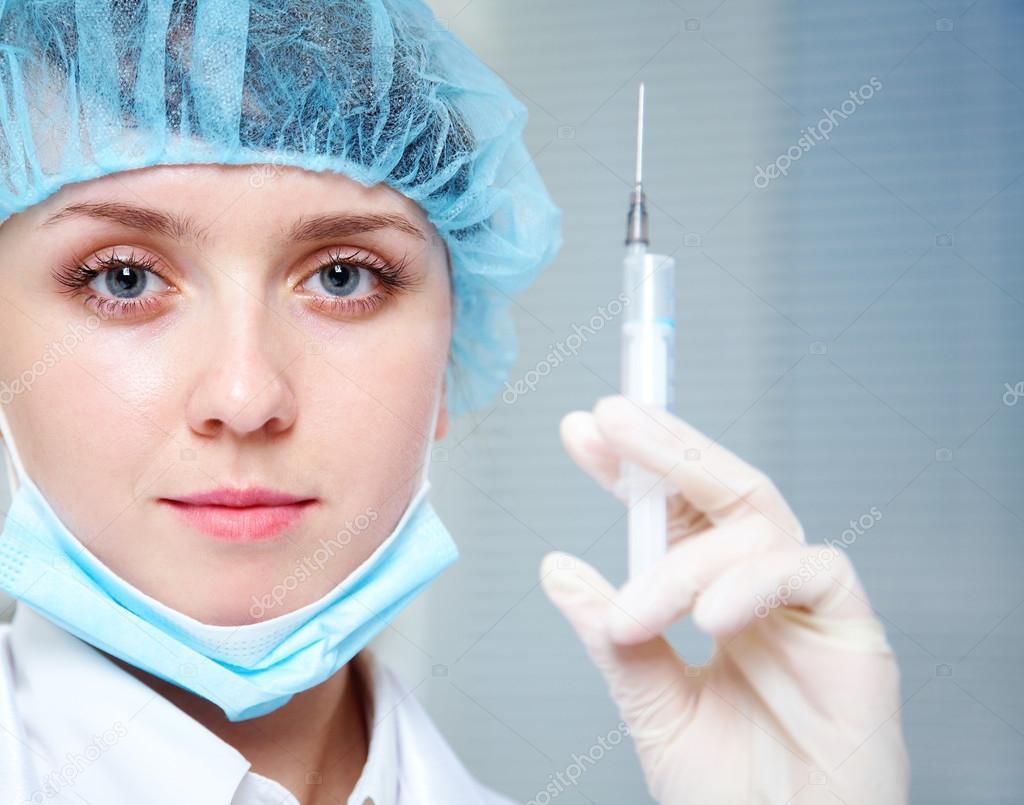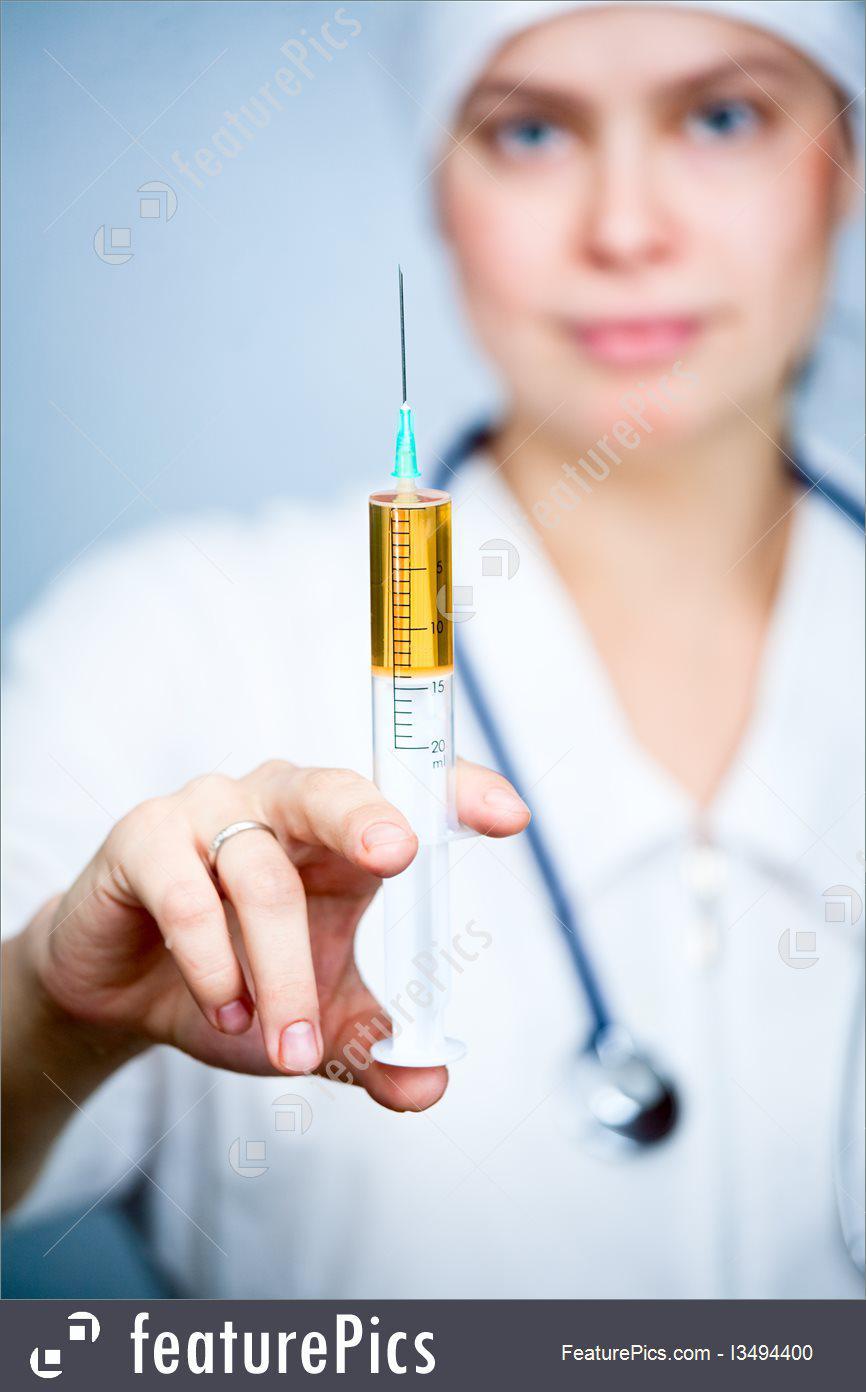The first image is the image on the left, the second image is the image on the right. Evaluate the accuracy of this statement regarding the images: "Two women are holding syringes.". Is it true? Answer yes or no. Yes. The first image is the image on the left, the second image is the image on the right. Examine the images to the left and right. Is the description "A person is holding a hypdermic needle in a gloved hand in one image." accurate? Answer yes or no. Yes. 